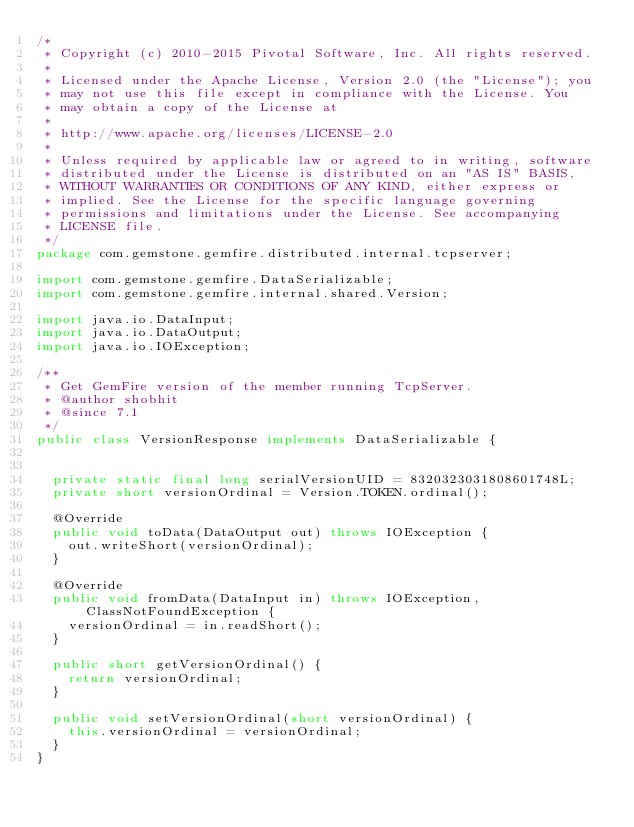<code> <loc_0><loc_0><loc_500><loc_500><_Java_>/*
 * Copyright (c) 2010-2015 Pivotal Software, Inc. All rights reserved.
 *
 * Licensed under the Apache License, Version 2.0 (the "License"); you
 * may not use this file except in compliance with the License. You
 * may obtain a copy of the License at
 *
 * http://www.apache.org/licenses/LICENSE-2.0
 *
 * Unless required by applicable law or agreed to in writing, software
 * distributed under the License is distributed on an "AS IS" BASIS,
 * WITHOUT WARRANTIES OR CONDITIONS OF ANY KIND, either express or
 * implied. See the License for the specific language governing
 * permissions and limitations under the License. See accompanying
 * LICENSE file.
 */
package com.gemstone.gemfire.distributed.internal.tcpserver;

import com.gemstone.gemfire.DataSerializable;
import com.gemstone.gemfire.internal.shared.Version;

import java.io.DataInput;
import java.io.DataOutput;
import java.io.IOException;

/**
 * Get GemFire version of the member running TcpServer.
 * @author shobhit
 * @since 7.1
 */
public class VersionResponse implements DataSerializable {


  private static final long serialVersionUID = 8320323031808601748L;
  private short versionOrdinal = Version.TOKEN.ordinal();

  @Override
  public void toData(DataOutput out) throws IOException {
    out.writeShort(versionOrdinal);
  }

  @Override
  public void fromData(DataInput in) throws IOException, ClassNotFoundException {
    versionOrdinal = in.readShort();
  }

  public short getVersionOrdinal() {
    return versionOrdinal;
  }

  public void setVersionOrdinal(short versionOrdinal) {
    this.versionOrdinal = versionOrdinal;
  }
}
</code> 